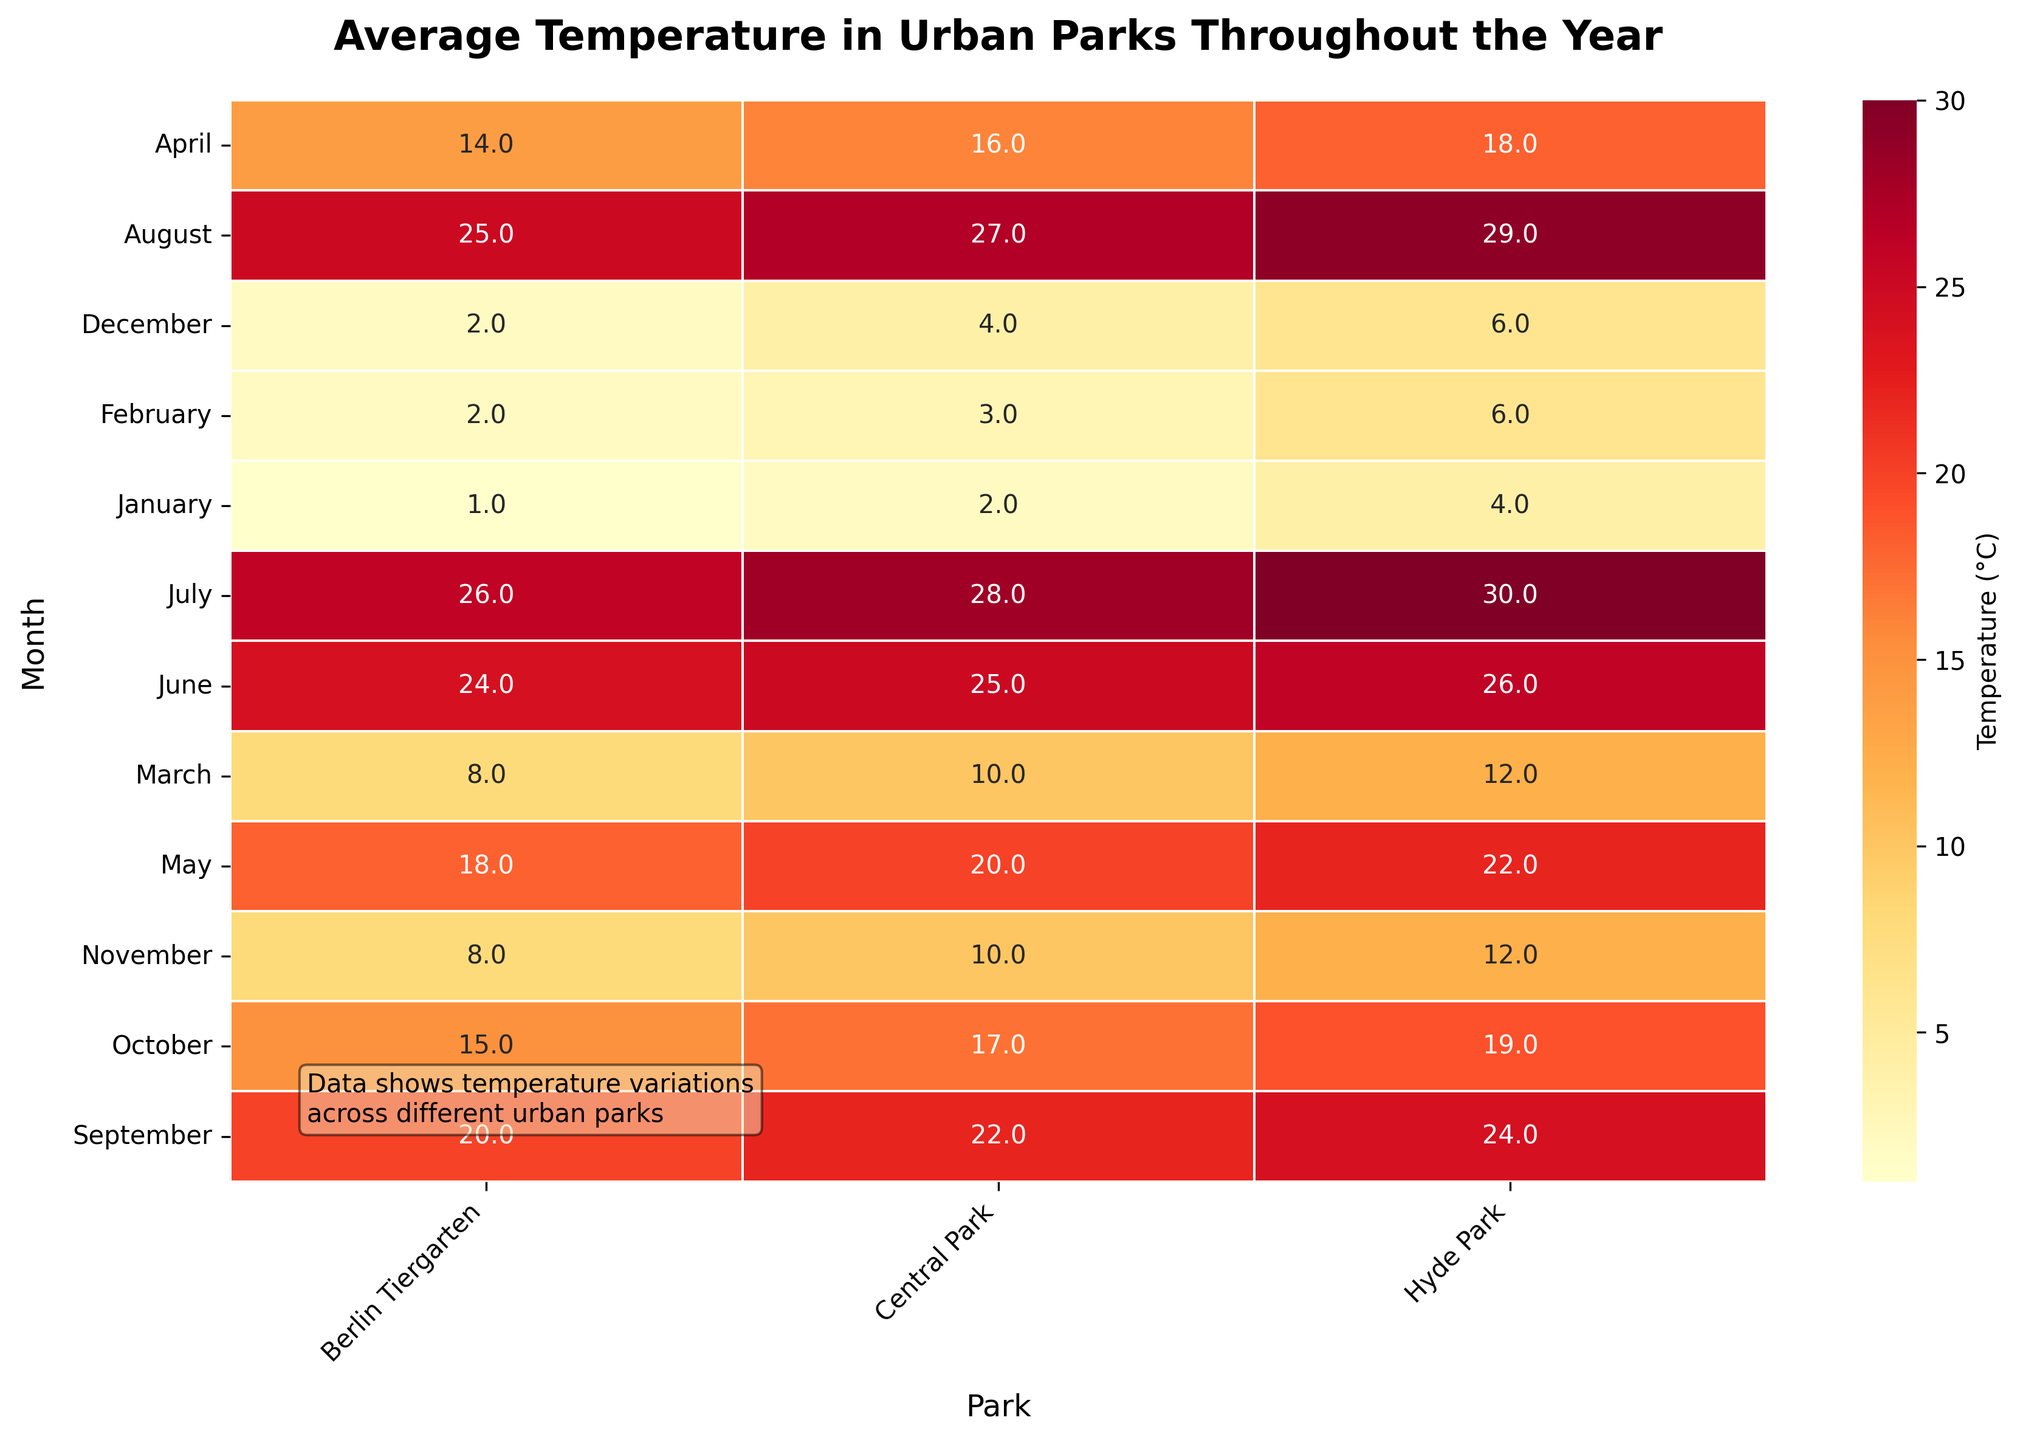What is the title of the figure? The title of a graph or figure is normally found at the top of the image, giving an overview of what the chart is about. In this case, we look to the top center of the plot to find the title.
Answer: Average Temperature in Urban Parks Throughout the Year Which park has the highest average temperature in July? Look at the cell corresponding to July and Hyde Park. The heatmap cell shows 30°C, which is under Hyde Park.
Answer: Hyde Park What are the average temperatures in Central Park during January and December? Locate the cells under the "Central Park" column for the months of January and December. The numbers in these cells are 2°C and 4°C, respectively.
Answer: 2°C, 4°C Which park has the lowest temperature in March? Look along the March row across all columns. The lowest value is under Berlin Tiergarten, which is 8°C.
Answer: Berlin Tiergarten How does the temperature in Hyde Park change from June to July? Compare the temperatures in Hyde Park for June (26°C) and July (30°C). Calculate the difference: 30°C - 26°C = 4°C.
Answer: Increases by 4°C What is the average temperature in Berlin Tiergarten for the first quarter of the year (January to March)? Average the temperature values for Berlin Tiergarten from January (1°C), February (2°C), and March (8°C). The calculation is (1 + 2 + 8) / 3 = 11 / 3 = 3.67°C, roughly 4°C.
Answer: 4°C Which month shows the highest overall temperature across all parks? Scan across each row (month) and locate the highest temperature value in the entire heatmap. The highest value is July in Hyde Park with 30°C.
Answer: July What is the difference in average temperature between Central Park and Hyde Park in October? Check the cells for October under both Central Park (17°C) and Hyde Park (19°C). Subtract 17°C from 19°C: 19 - 17 = 2°C.
Answer: 2°C How does the average temperature in Berlin Tiergarten in December compare to that in January? Look at Berlin Tiergarten's temperatures in December (2°C) and January (1°C). Since 2°C > 1°C, it is marginally higher.
Answer: It is 1°C higher in December What do the colors on the heatmap represent? This figure uses a heatmap where colors range from lighter to darker shades of yellow and red. These colors represent different temperature levels, with lighter colors indicating lower temperatures and darker colors indicating higher temperatures.
Answer: Different temperature levels with darker colors indicating higher temperatures 